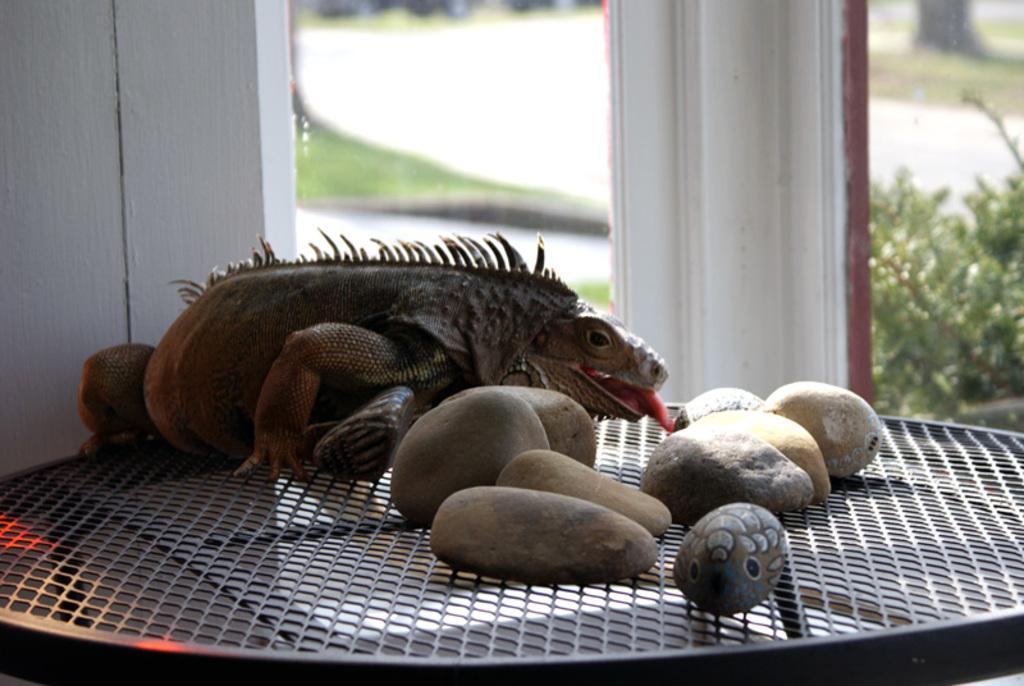Please provide a concise description of this image. In this picture we can see a frog, some stones on a mesh and in the background we can see pillars, plants. 